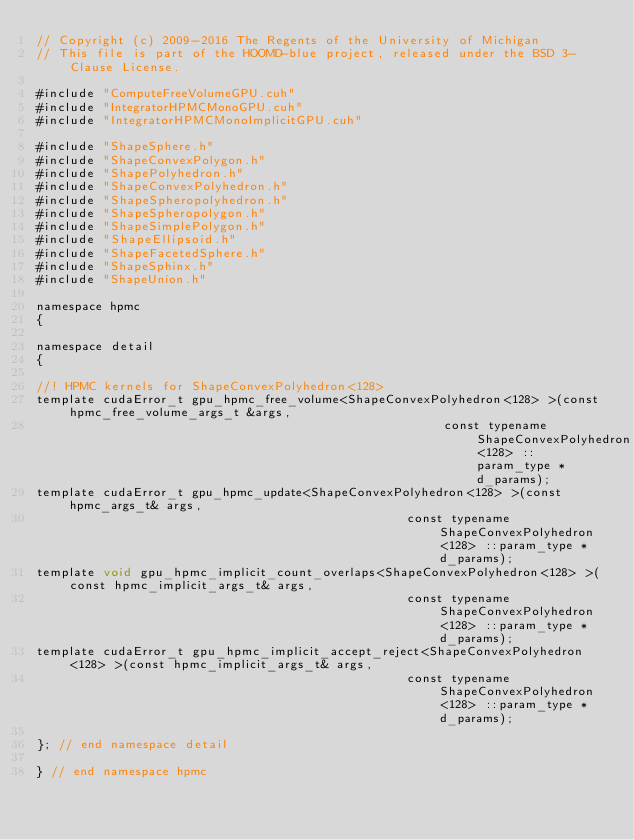Convert code to text. <code><loc_0><loc_0><loc_500><loc_500><_Cuda_>// Copyright (c) 2009-2016 The Regents of the University of Michigan
// This file is part of the HOOMD-blue project, released under the BSD 3-Clause License.

#include "ComputeFreeVolumeGPU.cuh"
#include "IntegratorHPMCMonoGPU.cuh"
#include "IntegratorHPMCMonoImplicitGPU.cuh"

#include "ShapeSphere.h"
#include "ShapeConvexPolygon.h"
#include "ShapePolyhedron.h"
#include "ShapeConvexPolyhedron.h"
#include "ShapeSpheropolyhedron.h"
#include "ShapeSpheropolygon.h"
#include "ShapeSimplePolygon.h"
#include "ShapeEllipsoid.h"
#include "ShapeFacetedSphere.h"
#include "ShapeSphinx.h"
#include "ShapeUnion.h"

namespace hpmc
{

namespace detail
{

//! HPMC kernels for ShapeConvexPolyhedron<128>
template cudaError_t gpu_hpmc_free_volume<ShapeConvexPolyhedron<128> >(const hpmc_free_volume_args_t &args,
                                                       const typename ShapeConvexPolyhedron<128> ::param_type *d_params);
template cudaError_t gpu_hpmc_update<ShapeConvexPolyhedron<128> >(const hpmc_args_t& args,
                                                  const typename ShapeConvexPolyhedron<128> ::param_type *d_params);
template void gpu_hpmc_implicit_count_overlaps<ShapeConvexPolyhedron<128> >(const hpmc_implicit_args_t& args,
                                                  const typename ShapeConvexPolyhedron<128> ::param_type *d_params);
template cudaError_t gpu_hpmc_implicit_accept_reject<ShapeConvexPolyhedron<128> >(const hpmc_implicit_args_t& args,
                                                  const typename ShapeConvexPolyhedron<128> ::param_type *d_params);

}; // end namespace detail

} // end namespace hpmc
</code> 